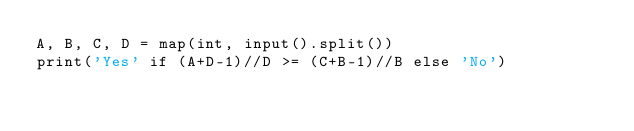Convert code to text. <code><loc_0><loc_0><loc_500><loc_500><_Python_>A, B, C, D = map(int, input().split())
print('Yes' if (A+D-1)//D >= (C+B-1)//B else 'No')</code> 